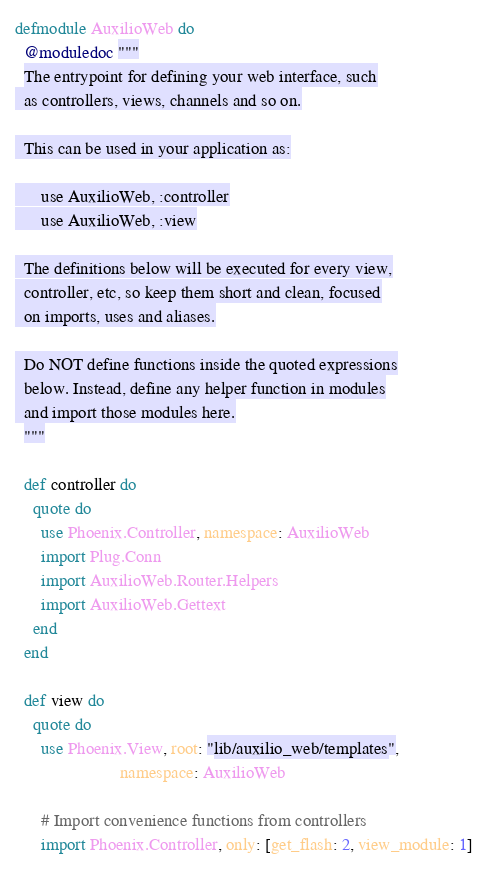Convert code to text. <code><loc_0><loc_0><loc_500><loc_500><_Elixir_>defmodule AuxilioWeb do
  @moduledoc """
  The entrypoint for defining your web interface, such
  as controllers, views, channels and so on.

  This can be used in your application as:

      use AuxilioWeb, :controller
      use AuxilioWeb, :view

  The definitions below will be executed for every view,
  controller, etc, so keep them short and clean, focused
  on imports, uses and aliases.

  Do NOT define functions inside the quoted expressions
  below. Instead, define any helper function in modules
  and import those modules here.
  """

  def controller do
    quote do
      use Phoenix.Controller, namespace: AuxilioWeb
      import Plug.Conn
      import AuxilioWeb.Router.Helpers
      import AuxilioWeb.Gettext
    end
  end

  def view do
    quote do
      use Phoenix.View, root: "lib/auxilio_web/templates",
                        namespace: AuxilioWeb

      # Import convenience functions from controllers
      import Phoenix.Controller, only: [get_flash: 2, view_module: 1]
</code> 